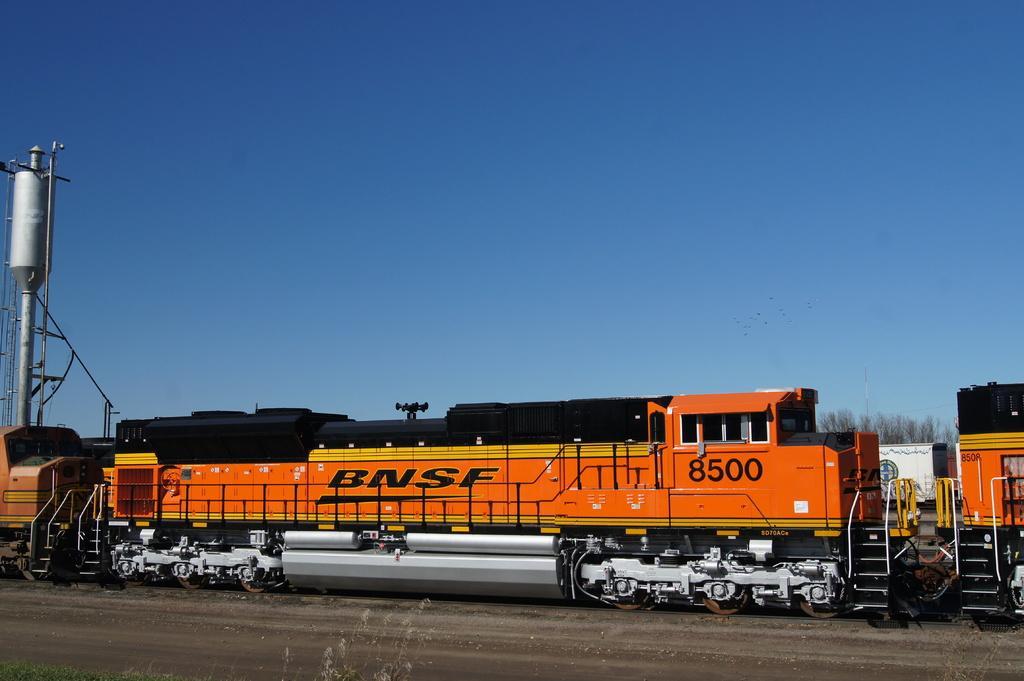Describe this image in one or two sentences. In this image, there is an orange color train on a railway track. Beside this railway track, there is a dry land. In the background, there is a tank attached to a pole, a white color box, there are trees and there is blue sky. 